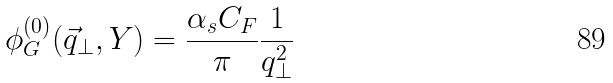<formula> <loc_0><loc_0><loc_500><loc_500>\phi ^ { ( 0 ) } _ { G } ( \vec { q } _ { \bot } , Y ) = \frac { \alpha _ { s } C _ { F } } { \pi } \frac { 1 } { q ^ { 2 } _ { \bot } }</formula> 